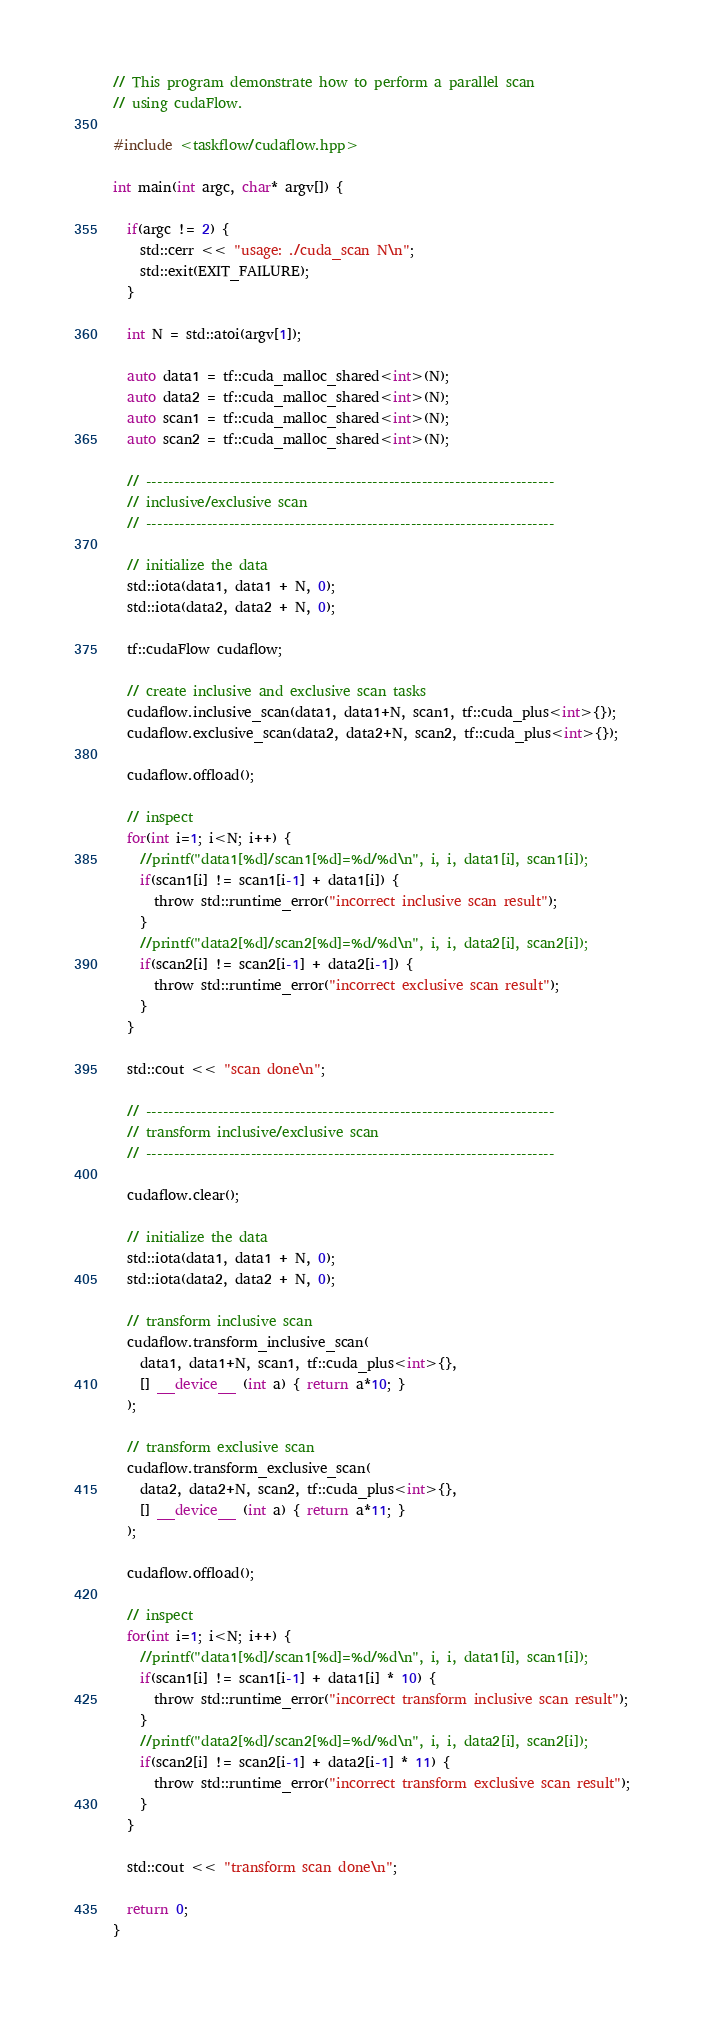Convert code to text. <code><loc_0><loc_0><loc_500><loc_500><_Cuda_>// This program demonstrate how to perform a parallel scan
// using cudaFlow.

#include <taskflow/cudaflow.hpp>

int main(int argc, char* argv[]) {

  if(argc != 2) {
    std::cerr << "usage: ./cuda_scan N\n";
    std::exit(EXIT_FAILURE);
  }

  int N = std::atoi(argv[1]);

  auto data1 = tf::cuda_malloc_shared<int>(N);
  auto data2 = tf::cuda_malloc_shared<int>(N);
  auto scan1 = tf::cuda_malloc_shared<int>(N);
  auto scan2 = tf::cuda_malloc_shared<int>(N);

  // --------------------------------------------------------------------------
  // inclusive/exclusive scan
  // --------------------------------------------------------------------------

  // initialize the data
  std::iota(data1, data1 + N, 0);
  std::iota(data2, data2 + N, 0);
  
  tf::cudaFlow cudaflow;
  
  // create inclusive and exclusive scan tasks
  cudaflow.inclusive_scan(data1, data1+N, scan1, tf::cuda_plus<int>{});
  cudaflow.exclusive_scan(data2, data2+N, scan2, tf::cuda_plus<int>{});

  cudaflow.offload();
  
  // inspect 
  for(int i=1; i<N; i++) {
    //printf("data1[%d]/scan1[%d]=%d/%d\n", i, i, data1[i], scan1[i]);
    if(scan1[i] != scan1[i-1] + data1[i]) {
      throw std::runtime_error("incorrect inclusive scan result");
    }
    //printf("data2[%d]/scan2[%d]=%d/%d\n", i, i, data2[i], scan2[i]);
    if(scan2[i] != scan2[i-1] + data2[i-1]) {
      throw std::runtime_error("incorrect exclusive scan result");
    }
  }

  std::cout << "scan done\n";
  
  // --------------------------------------------------------------------------
  // transform inclusive/exclusive scan
  // --------------------------------------------------------------------------
  
  cudaflow.clear();

  // initialize the data
  std::iota(data1, data1 + N, 0);
  std::iota(data2, data2 + N, 0);
  
  // transform inclusive scan
  cudaflow.transform_inclusive_scan(
    data1, data1+N, scan1, tf::cuda_plus<int>{},
    [] __device__ (int a) { return a*10; }
  );

  // transform exclusive scan
  cudaflow.transform_exclusive_scan(
    data2, data2+N, scan2, tf::cuda_plus<int>{},
    [] __device__ (int a) { return a*11; }
  );

  cudaflow.offload();
  
  // inspect 
  for(int i=1; i<N; i++) {
    //printf("data1[%d]/scan1[%d]=%d/%d\n", i, i, data1[i], scan1[i]);
    if(scan1[i] != scan1[i-1] + data1[i] * 10) {
      throw std::runtime_error("incorrect transform inclusive scan result");
    }
    //printf("data2[%d]/scan2[%d]=%d/%d\n", i, i, data2[i], scan2[i]);
    if(scan2[i] != scan2[i-1] + data2[i-1] * 11) {
      throw std::runtime_error("incorrect transform exclusive scan result");
    }
  }

  std::cout << "transform scan done\n";

  return 0;
}


</code> 